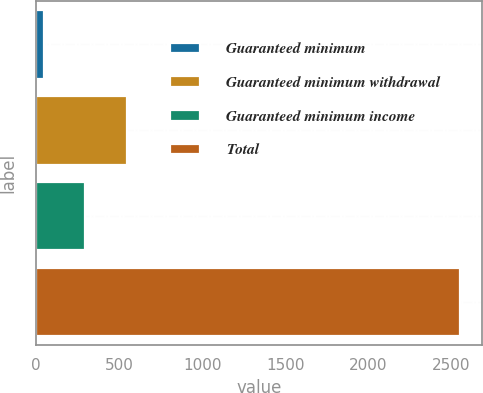Convert chart to OTSL. <chart><loc_0><loc_0><loc_500><loc_500><bar_chart><fcel>Guaranteed minimum<fcel>Guaranteed minimum withdrawal<fcel>Guaranteed minimum income<fcel>Total<nl><fcel>44<fcel>546.4<fcel>295.2<fcel>2556<nl></chart> 